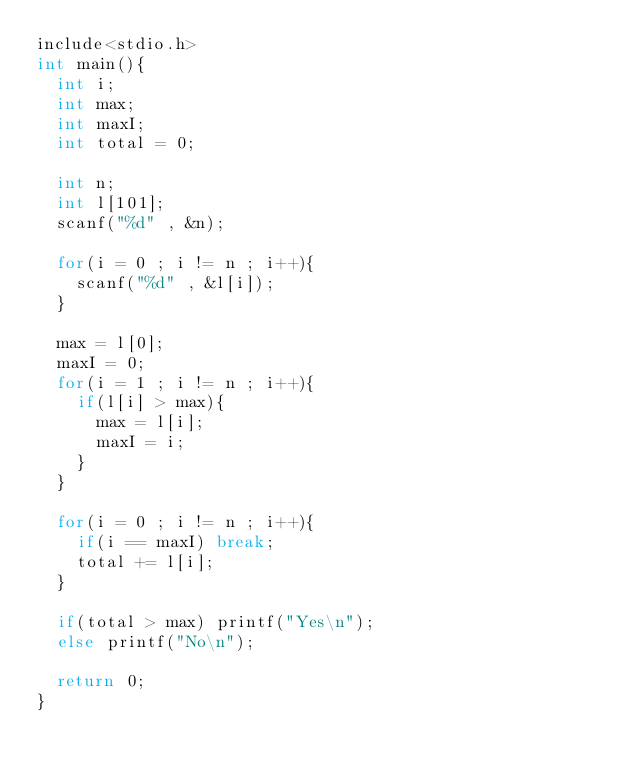<code> <loc_0><loc_0><loc_500><loc_500><_C_>include<stdio.h>
int main(){
	int i;
	int max;
	int maxI;
	int total = 0;
	
	int n;
	int l[101];
	scanf("%d" , &n);
	
	for(i = 0 ; i != n ; i++){
		scanf("%d" , &l[i]);
	}
	
	max = l[0];
	maxI = 0;	
	for(i = 1 ; i != n ; i++){
		if(l[i] > max){
			max = l[i];
			maxI = i;
		}
	}

	for(i = 0 ; i != n ; i++){
		if(i == maxI) break;
		total += l[i];
	}	
		
	if(total > max) printf("Yes\n");
	else printf("No\n");
		
	return 0;
}</code> 